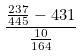<formula> <loc_0><loc_0><loc_500><loc_500>\frac { \frac { 2 3 7 } { 4 4 5 } - 4 3 1 } { \frac { 1 0 } { 1 6 4 } }</formula> 